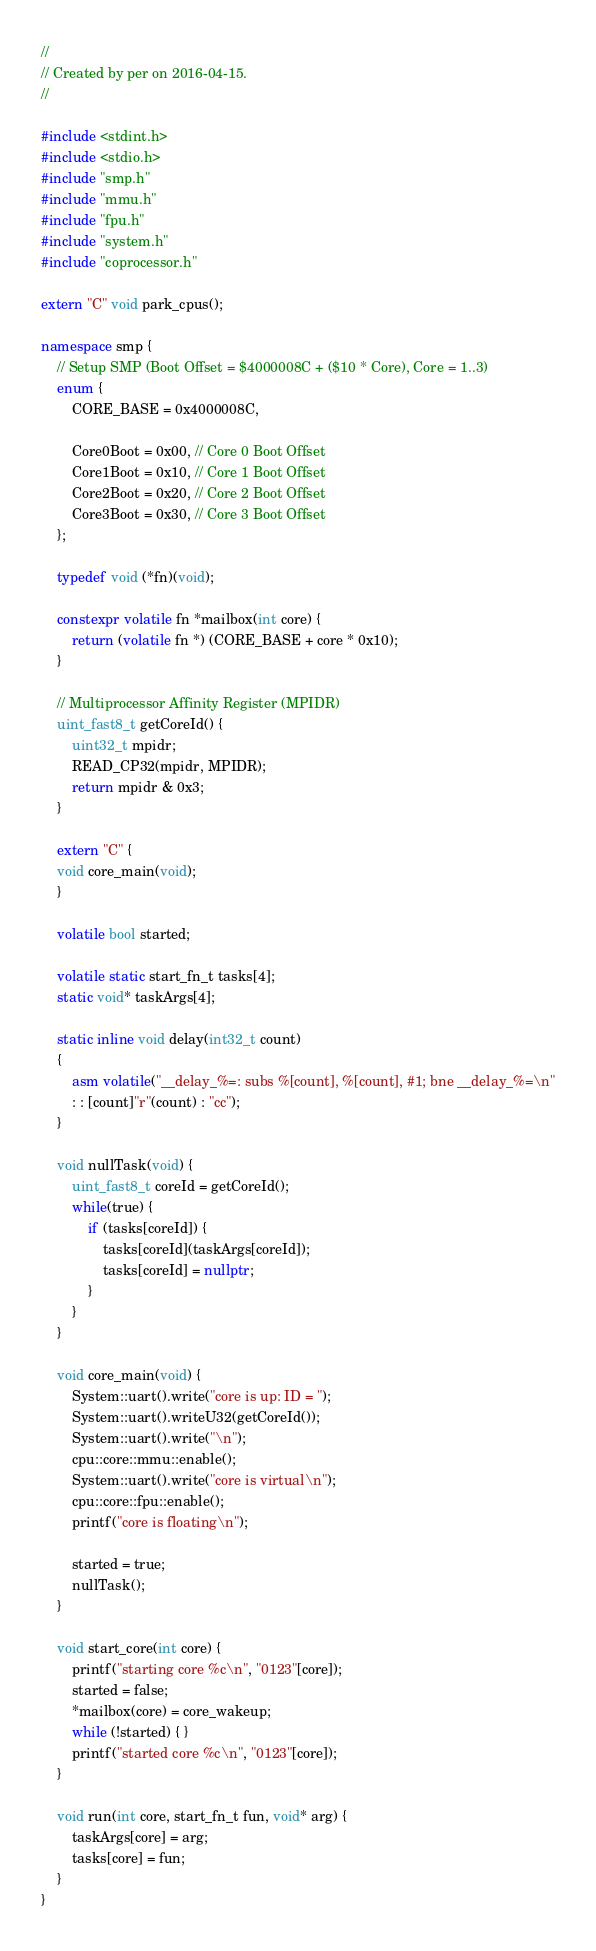Convert code to text. <code><loc_0><loc_0><loc_500><loc_500><_C++_>//
// Created by per on 2016-04-15.
//

#include <stdint.h>
#include <stdio.h>
#include "smp.h"
#include "mmu.h"
#include "fpu.h"
#include "system.h"
#include "coprocessor.h"

extern "C" void park_cpus();

namespace smp {
    // Setup SMP (Boot Offset = $4000008C + ($10 * Core), Core = 1..3)
    enum {
        CORE_BASE = 0x4000008C,

        Core0Boot = 0x00, // Core 0 Boot Offset
        Core1Boot = 0x10, // Core 1 Boot Offset
        Core2Boot = 0x20, // Core 2 Boot Offset
        Core3Boot = 0x30, // Core 3 Boot Offset
    };

    typedef void (*fn)(void);

    constexpr volatile fn *mailbox(int core) {
        return (volatile fn *) (CORE_BASE + core * 0x10);
    }

    // Multiprocessor Affinity Register (MPIDR)
    uint_fast8_t getCoreId() {
        uint32_t mpidr;
        READ_CP32(mpidr, MPIDR);
        return mpidr & 0x3;
    }

    extern "C" {
    void core_main(void);
    }

    volatile bool started;

    volatile static start_fn_t tasks[4];
    static void* taskArgs[4];

    static inline void delay(int32_t count)
    {
        asm volatile("__delay_%=: subs %[count], %[count], #1; bne __delay_%=\n"
        : : [count]"r"(count) : "cc");
    }

    void nullTask(void) {
        uint_fast8_t coreId = getCoreId();
        while(true) {
            if (tasks[coreId]) {
                tasks[coreId](taskArgs[coreId]);
                tasks[coreId] = nullptr;
            }
        }
    }

    void core_main(void) {
        System::uart().write("core is up: ID = ");
        System::uart().writeU32(getCoreId());
        System::uart().write("\n");
        cpu::core::mmu::enable();
        System::uart().write("core is virtual\n");
        cpu::core::fpu::enable();
        printf("core is floating\n");

        started = true;
        nullTask();
    }

    void start_core(int core) {
        printf("starting core %c\n", "0123"[core]);
        started = false;
        *mailbox(core) = core_wakeup;
        while (!started) { }
        printf("started core %c\n", "0123"[core]);
    }

    void run(int core, start_fn_t fun, void* arg) {
        taskArgs[core] = arg;
        tasks[core] = fun;
    }
}
</code> 